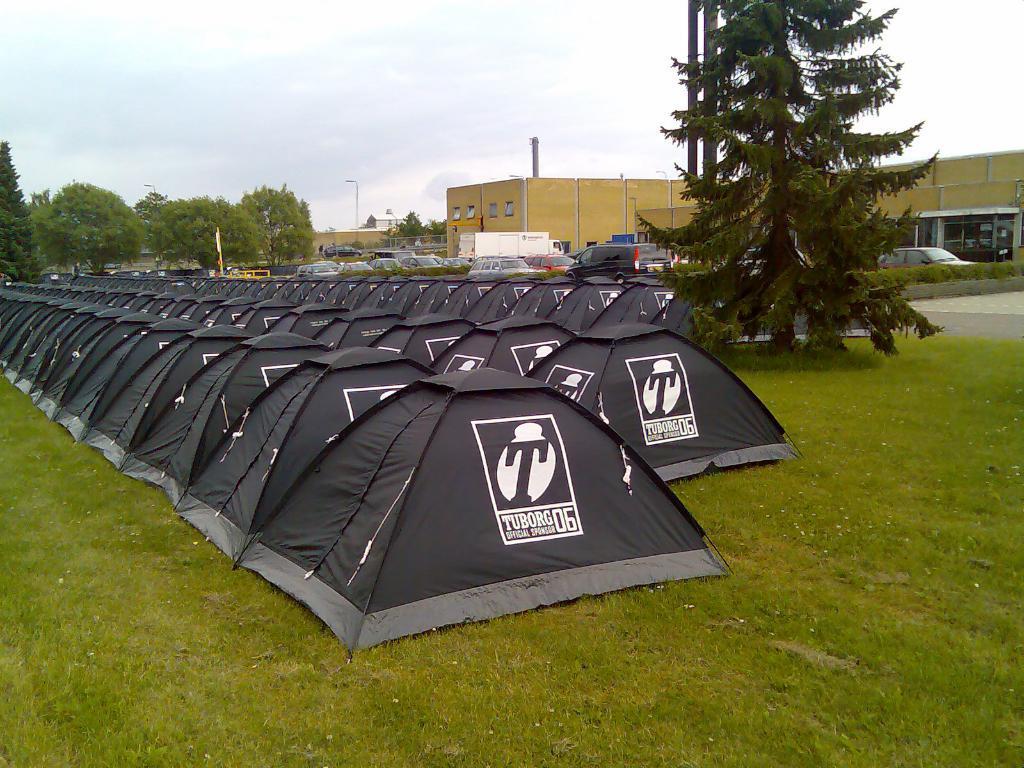Describe this image in one or two sentences. In this picture we can see tents, at the bottom there is grass, we can see some vehicles and plants in the middle, in the background there are buildings and trees, we can see the sky at the top of the picture. 